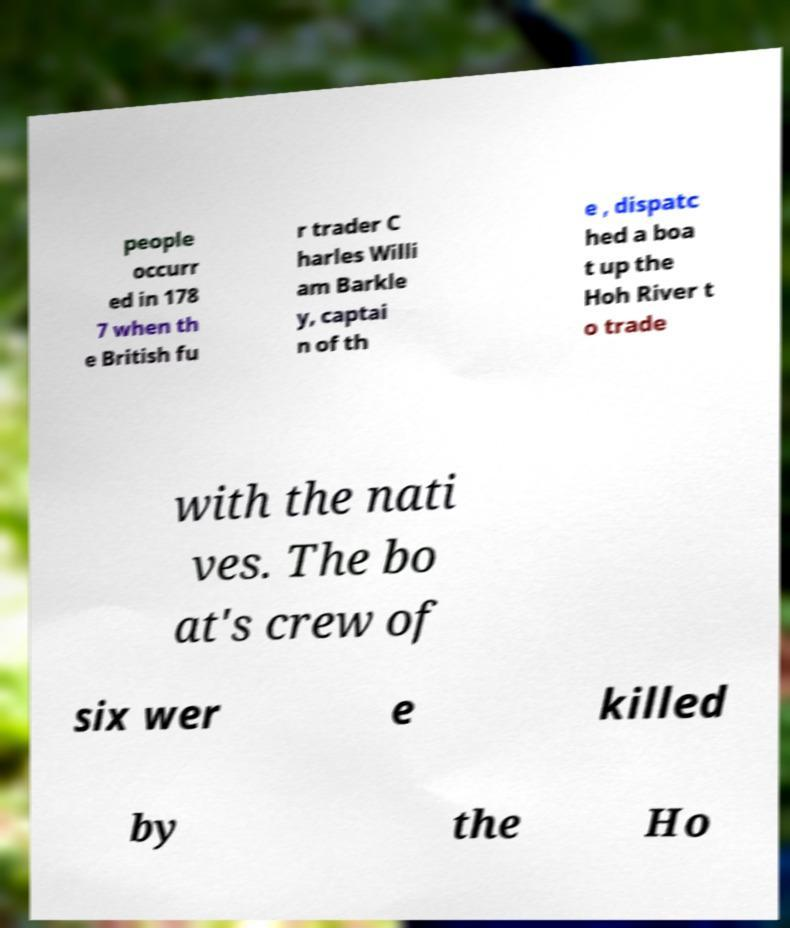Can you read and provide the text displayed in the image?This photo seems to have some interesting text. Can you extract and type it out for me? people occurr ed in 178 7 when th e British fu r trader C harles Willi am Barkle y, captai n of th e , dispatc hed a boa t up the Hoh River t o trade with the nati ves. The bo at's crew of six wer e killed by the Ho 